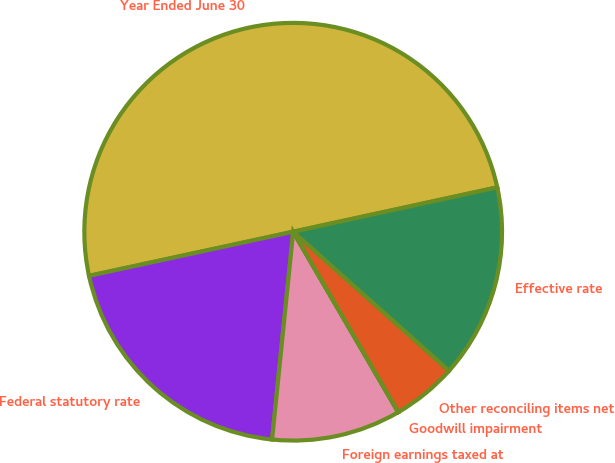<chart> <loc_0><loc_0><loc_500><loc_500><pie_chart><fcel>Year Ended June 30<fcel>Federal statutory rate<fcel>Foreign earnings taxed at<fcel>Goodwill impairment<fcel>Other reconciling items net<fcel>Effective rate<nl><fcel>49.98%<fcel>20.0%<fcel>10.0%<fcel>0.01%<fcel>5.01%<fcel>15.0%<nl></chart> 